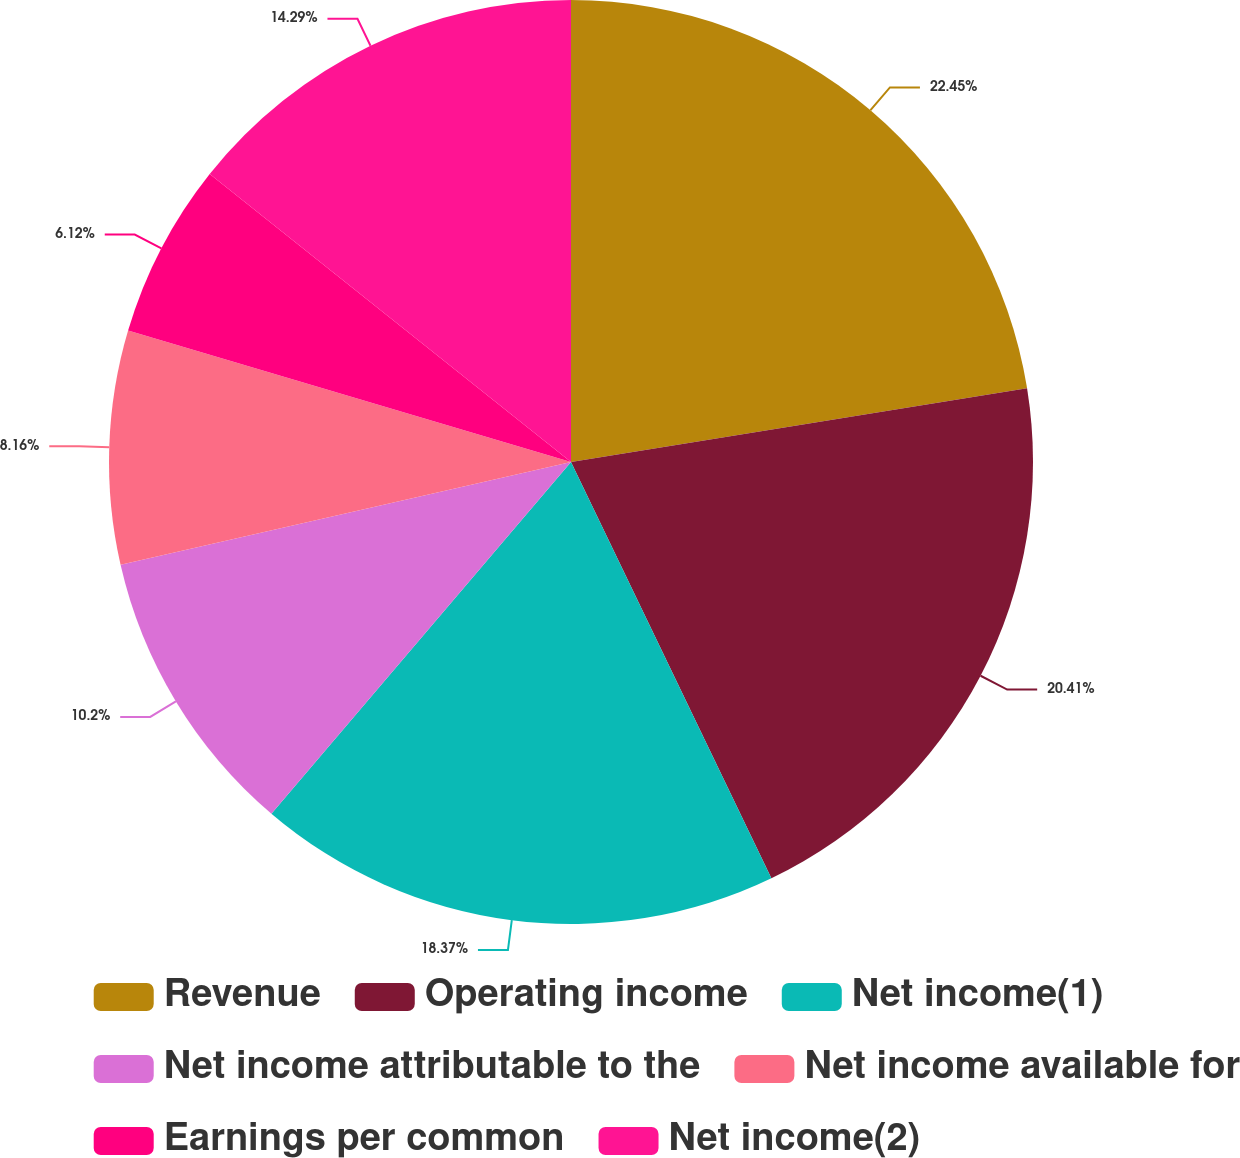Convert chart. <chart><loc_0><loc_0><loc_500><loc_500><pie_chart><fcel>Revenue<fcel>Operating income<fcel>Net income(1)<fcel>Net income attributable to the<fcel>Net income available for<fcel>Earnings per common<fcel>Net income(2)<nl><fcel>22.45%<fcel>20.41%<fcel>18.37%<fcel>10.2%<fcel>8.16%<fcel>6.12%<fcel>14.29%<nl></chart> 